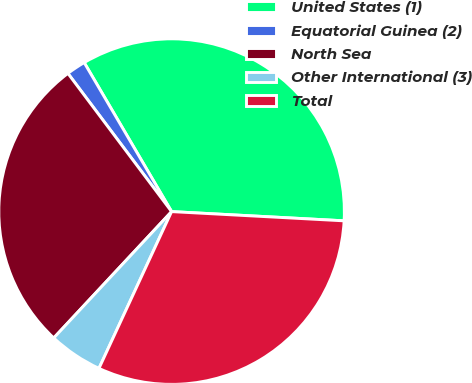Convert chart to OTSL. <chart><loc_0><loc_0><loc_500><loc_500><pie_chart><fcel>United States (1)<fcel>Equatorial Guinea (2)<fcel>North Sea<fcel>Other International (3)<fcel>Total<nl><fcel>34.29%<fcel>1.8%<fcel>27.81%<fcel>5.04%<fcel>31.05%<nl></chart> 